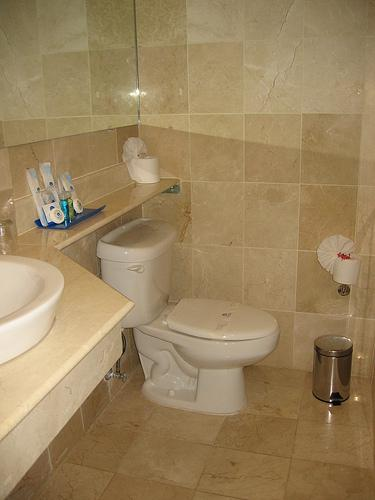Question: where is the soap?
Choices:
A. In the shower.
B. On the soap dish.
C. On the counter.
D. In the bottle.
Answer with the letter. Answer: C Question: where is the white handle?
Choices:
A. On the toilet.
B. On the refridgerator.
C. On the front door.
D. On the car door.
Answer with the letter. Answer: A Question: what color is the floor?
Choices:
A. Red.
B. Tan.
C. Black.
D. Brown.
Answer with the letter. Answer: B 